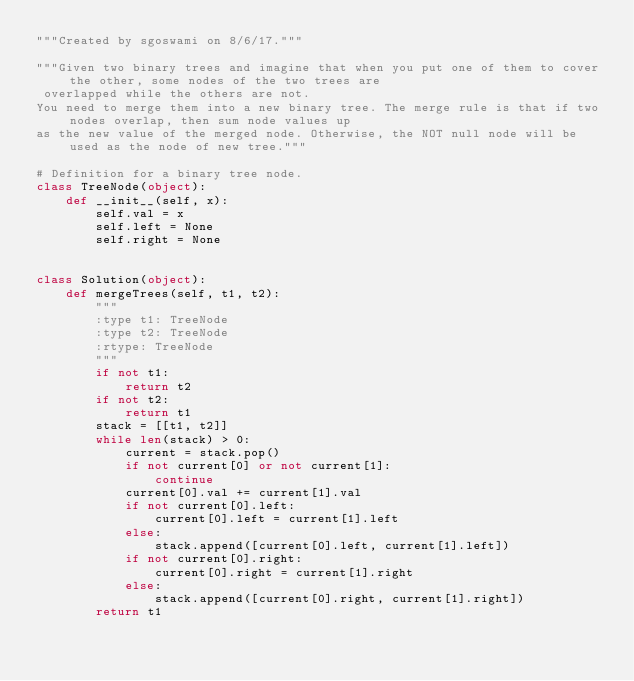Convert code to text. <code><loc_0><loc_0><loc_500><loc_500><_Python_>"""Created by sgoswami on 8/6/17."""

"""Given two binary trees and imagine that when you put one of them to cover the other, some nodes of the two trees are
 overlapped while the others are not.
You need to merge them into a new binary tree. The merge rule is that if two nodes overlap, then sum node values up 
as the new value of the merged node. Otherwise, the NOT null node will be used as the node of new tree."""

# Definition for a binary tree node.
class TreeNode(object):
    def __init__(self, x):
        self.val = x
        self.left = None
        self.right = None


class Solution(object):
    def mergeTrees(self, t1, t2):
        """
        :type t1: TreeNode
        :type t2: TreeNode
        :rtype: TreeNode
        """
        if not t1:
            return t2
        if not t2:
            return t1
        stack = [[t1, t2]]
        while len(stack) > 0:
            current = stack.pop()
            if not current[0] or not current[1]:
                continue
            current[0].val += current[1].val
            if not current[0].left:
                current[0].left = current[1].left
            else:
                stack.append([current[0].left, current[1].left])
            if not current[0].right:
                current[0].right = current[1].right
            else:
                stack.append([current[0].right, current[1].right])
        return t1



</code> 